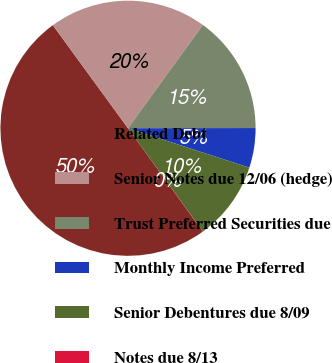Convert chart to OTSL. <chart><loc_0><loc_0><loc_500><loc_500><pie_chart><fcel>Related Debt<fcel>Senior Notes due 12/06 (hedge)<fcel>Trust Preferred Securities due<fcel>Monthly Income Preferred<fcel>Senior Debentures due 8/09<fcel>Notes due 8/13<nl><fcel>49.95%<fcel>20.0%<fcel>15.0%<fcel>5.02%<fcel>10.01%<fcel>0.02%<nl></chart> 